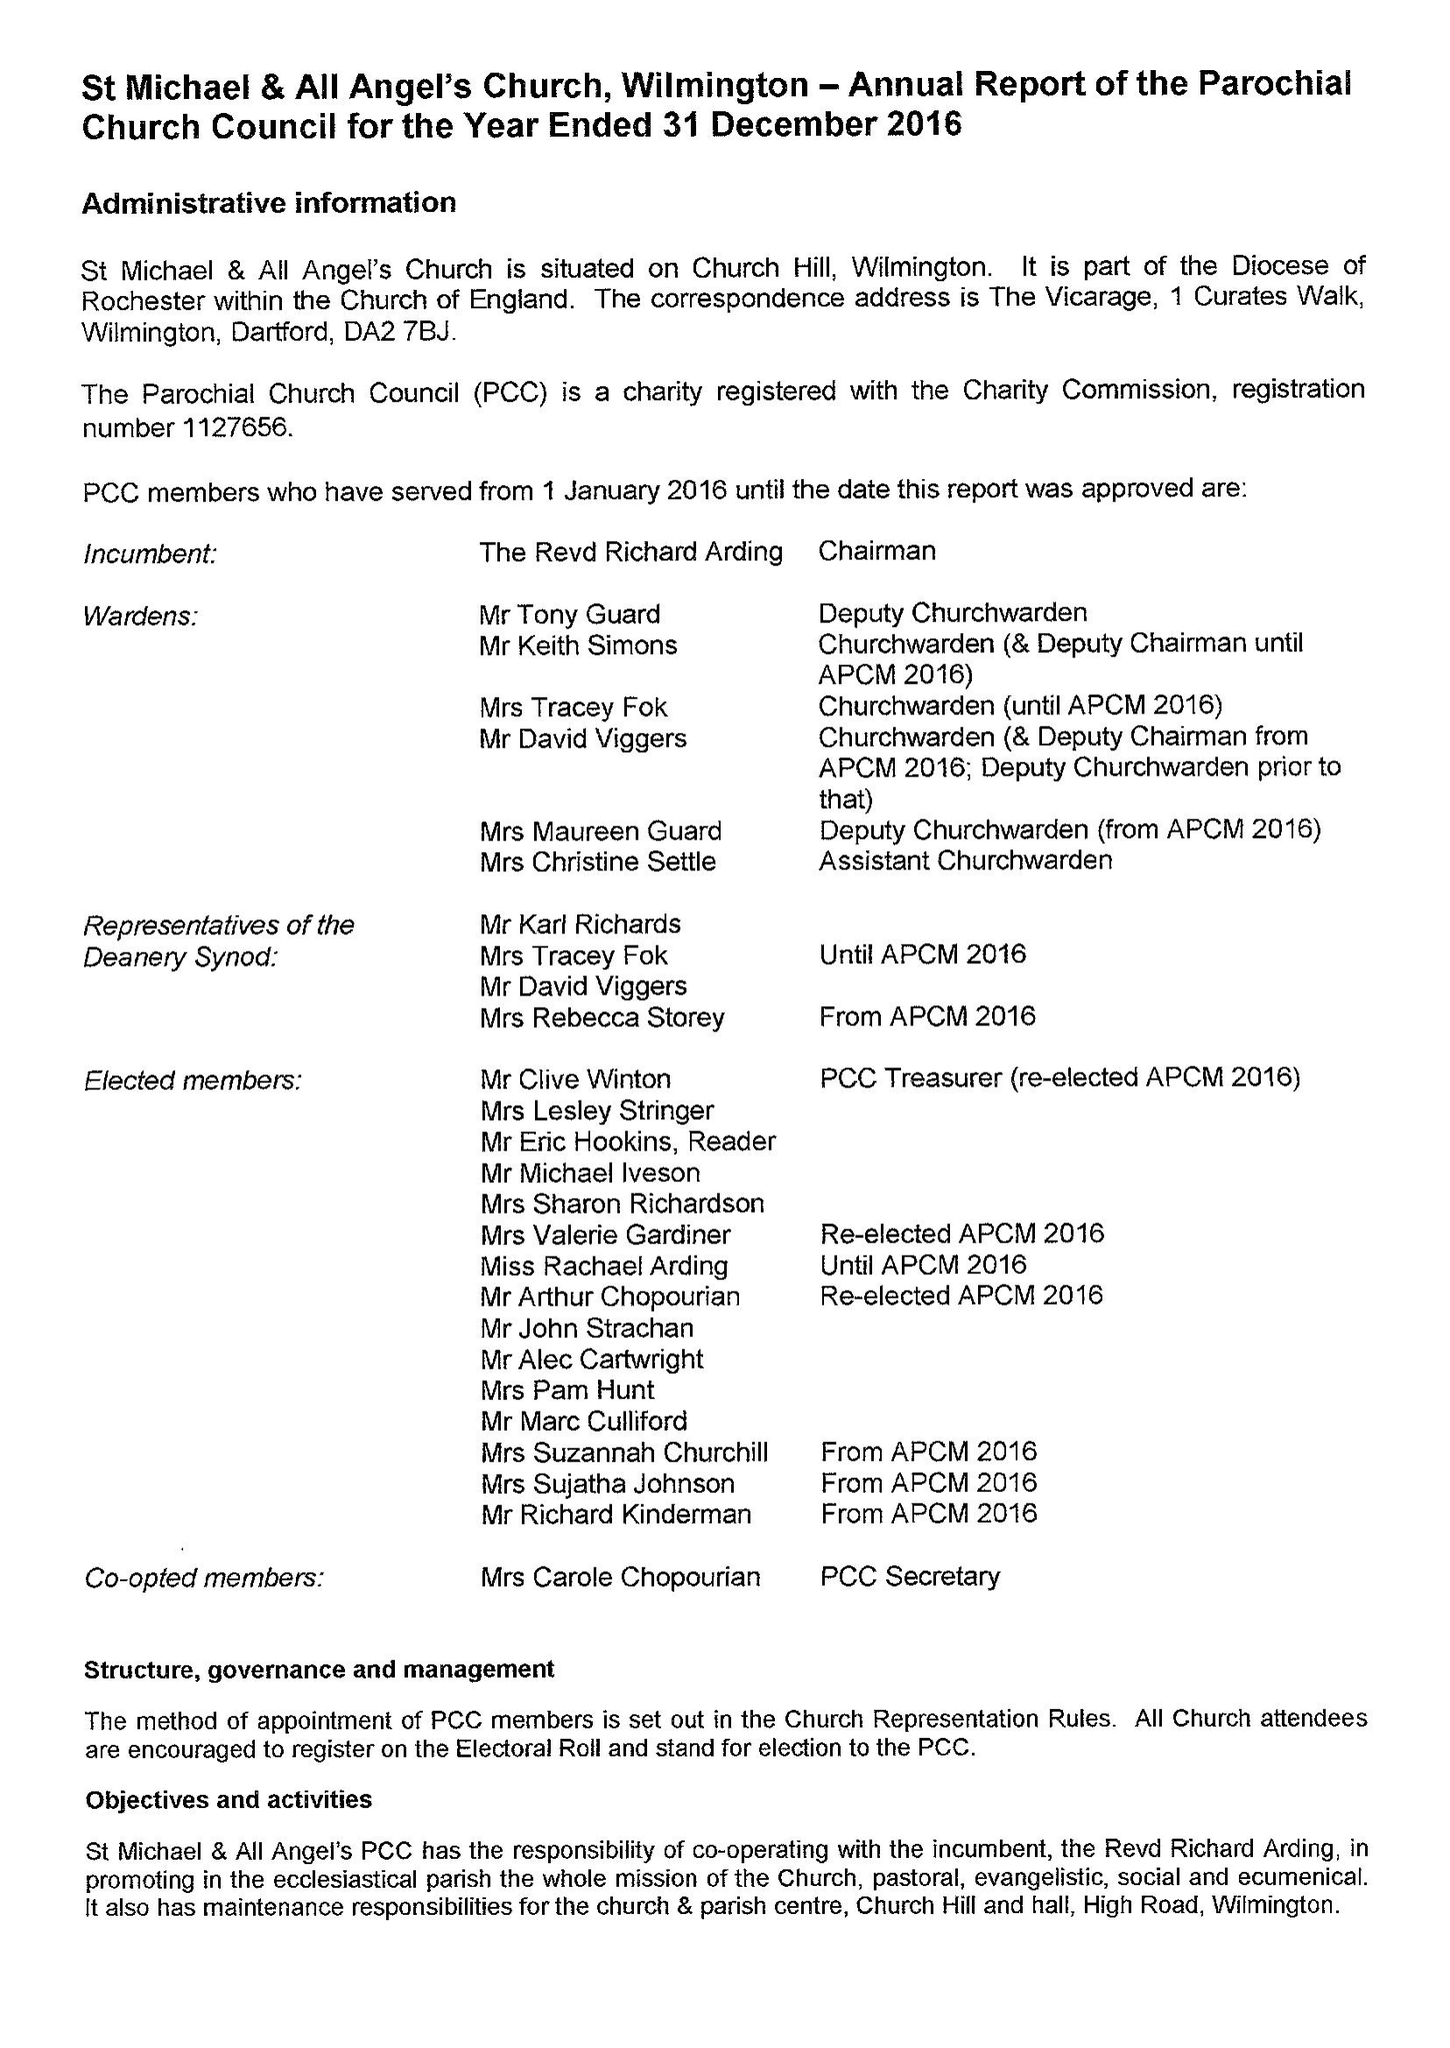What is the value for the charity_name?
Answer the question using a single word or phrase. The Parochial Church Council Of The Ecclesiastical Parish Of St Michael and All Angels, Wilmington 